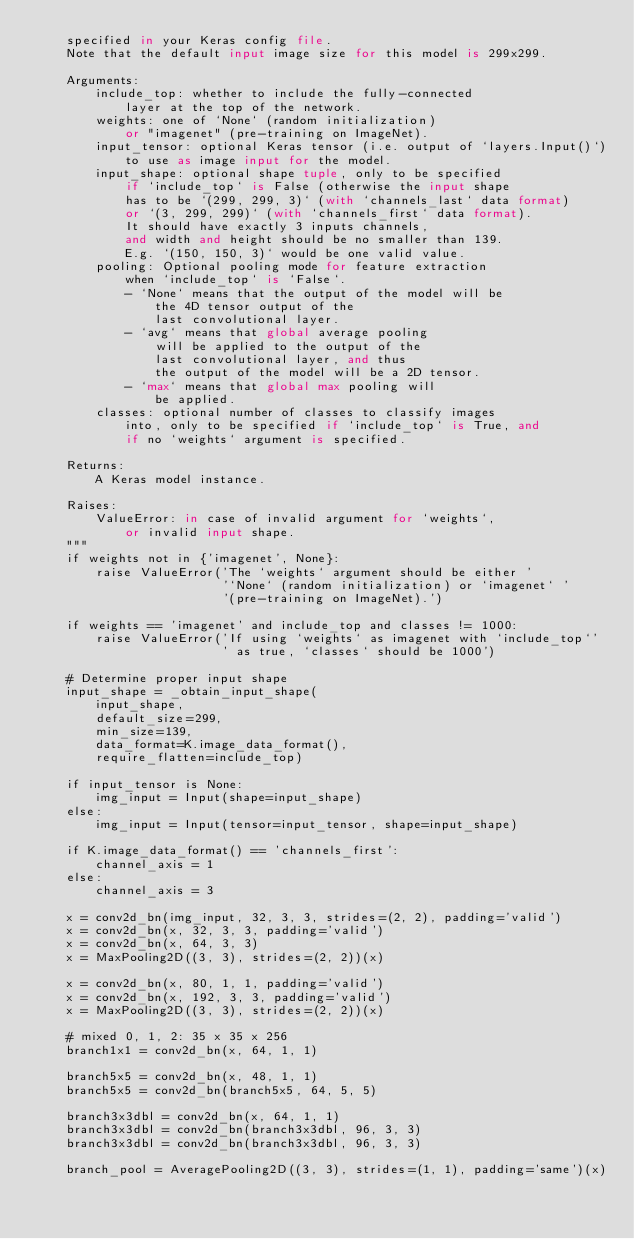Convert code to text. <code><loc_0><loc_0><loc_500><loc_500><_Python_>    specified in your Keras config file.
    Note that the default input image size for this model is 299x299.

    Arguments:
        include_top: whether to include the fully-connected
            layer at the top of the network.
        weights: one of `None` (random initialization)
            or "imagenet" (pre-training on ImageNet).
        input_tensor: optional Keras tensor (i.e. output of `layers.Input()`)
            to use as image input for the model.
        input_shape: optional shape tuple, only to be specified
            if `include_top` is False (otherwise the input shape
            has to be `(299, 299, 3)` (with `channels_last` data format)
            or `(3, 299, 299)` (with `channels_first` data format).
            It should have exactly 3 inputs channels,
            and width and height should be no smaller than 139.
            E.g. `(150, 150, 3)` would be one valid value.
        pooling: Optional pooling mode for feature extraction
            when `include_top` is `False`.
            - `None` means that the output of the model will be
                the 4D tensor output of the
                last convolutional layer.
            - `avg` means that global average pooling
                will be applied to the output of the
                last convolutional layer, and thus
                the output of the model will be a 2D tensor.
            - `max` means that global max pooling will
                be applied.
        classes: optional number of classes to classify images
            into, only to be specified if `include_top` is True, and
            if no `weights` argument is specified.

    Returns:
        A Keras model instance.

    Raises:
        ValueError: in case of invalid argument for `weights`,
            or invalid input shape.
    """
    if weights not in {'imagenet', None}:
        raise ValueError('The `weights` argument should be either '
                         '`None` (random initialization) or `imagenet` '
                         '(pre-training on ImageNet).')

    if weights == 'imagenet' and include_top and classes != 1000:
        raise ValueError('If using `weights` as imagenet with `include_top`'
                         ' as true, `classes` should be 1000')

    # Determine proper input shape
    input_shape = _obtain_input_shape(
        input_shape,
        default_size=299,
        min_size=139,
        data_format=K.image_data_format(),
        require_flatten=include_top)

    if input_tensor is None:
        img_input = Input(shape=input_shape)
    else:
        img_input = Input(tensor=input_tensor, shape=input_shape)

    if K.image_data_format() == 'channels_first':
        channel_axis = 1
    else:
        channel_axis = 3

    x = conv2d_bn(img_input, 32, 3, 3, strides=(2, 2), padding='valid')
    x = conv2d_bn(x, 32, 3, 3, padding='valid')
    x = conv2d_bn(x, 64, 3, 3)
    x = MaxPooling2D((3, 3), strides=(2, 2))(x)

    x = conv2d_bn(x, 80, 1, 1, padding='valid')
    x = conv2d_bn(x, 192, 3, 3, padding='valid')
    x = MaxPooling2D((3, 3), strides=(2, 2))(x)

    # mixed 0, 1, 2: 35 x 35 x 256
    branch1x1 = conv2d_bn(x, 64, 1, 1)

    branch5x5 = conv2d_bn(x, 48, 1, 1)
    branch5x5 = conv2d_bn(branch5x5, 64, 5, 5)

    branch3x3dbl = conv2d_bn(x, 64, 1, 1)
    branch3x3dbl = conv2d_bn(branch3x3dbl, 96, 3, 3)
    branch3x3dbl = conv2d_bn(branch3x3dbl, 96, 3, 3)

    branch_pool = AveragePooling2D((3, 3), strides=(1, 1), padding='same')(x)</code> 